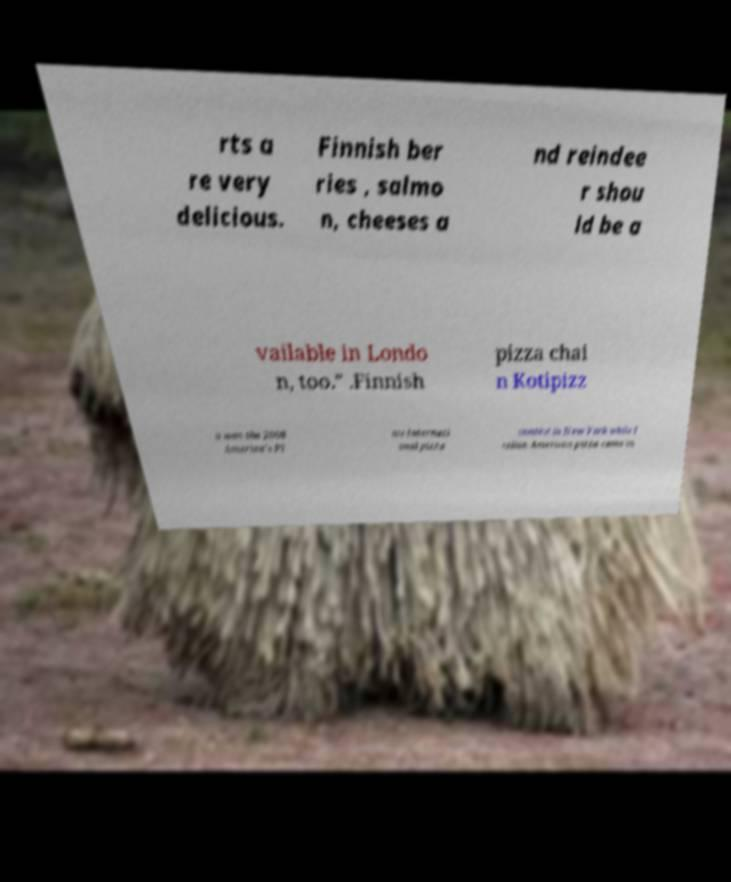Please read and relay the text visible in this image. What does it say? rts a re very delicious. Finnish ber ries , salmo n, cheeses a nd reindee r shou ld be a vailable in Londo n, too." .Finnish pizza chai n Kotipizz a won the 2008 America's Pl ate Internati onal pizza contest in New York while I talian-American pizza came in 